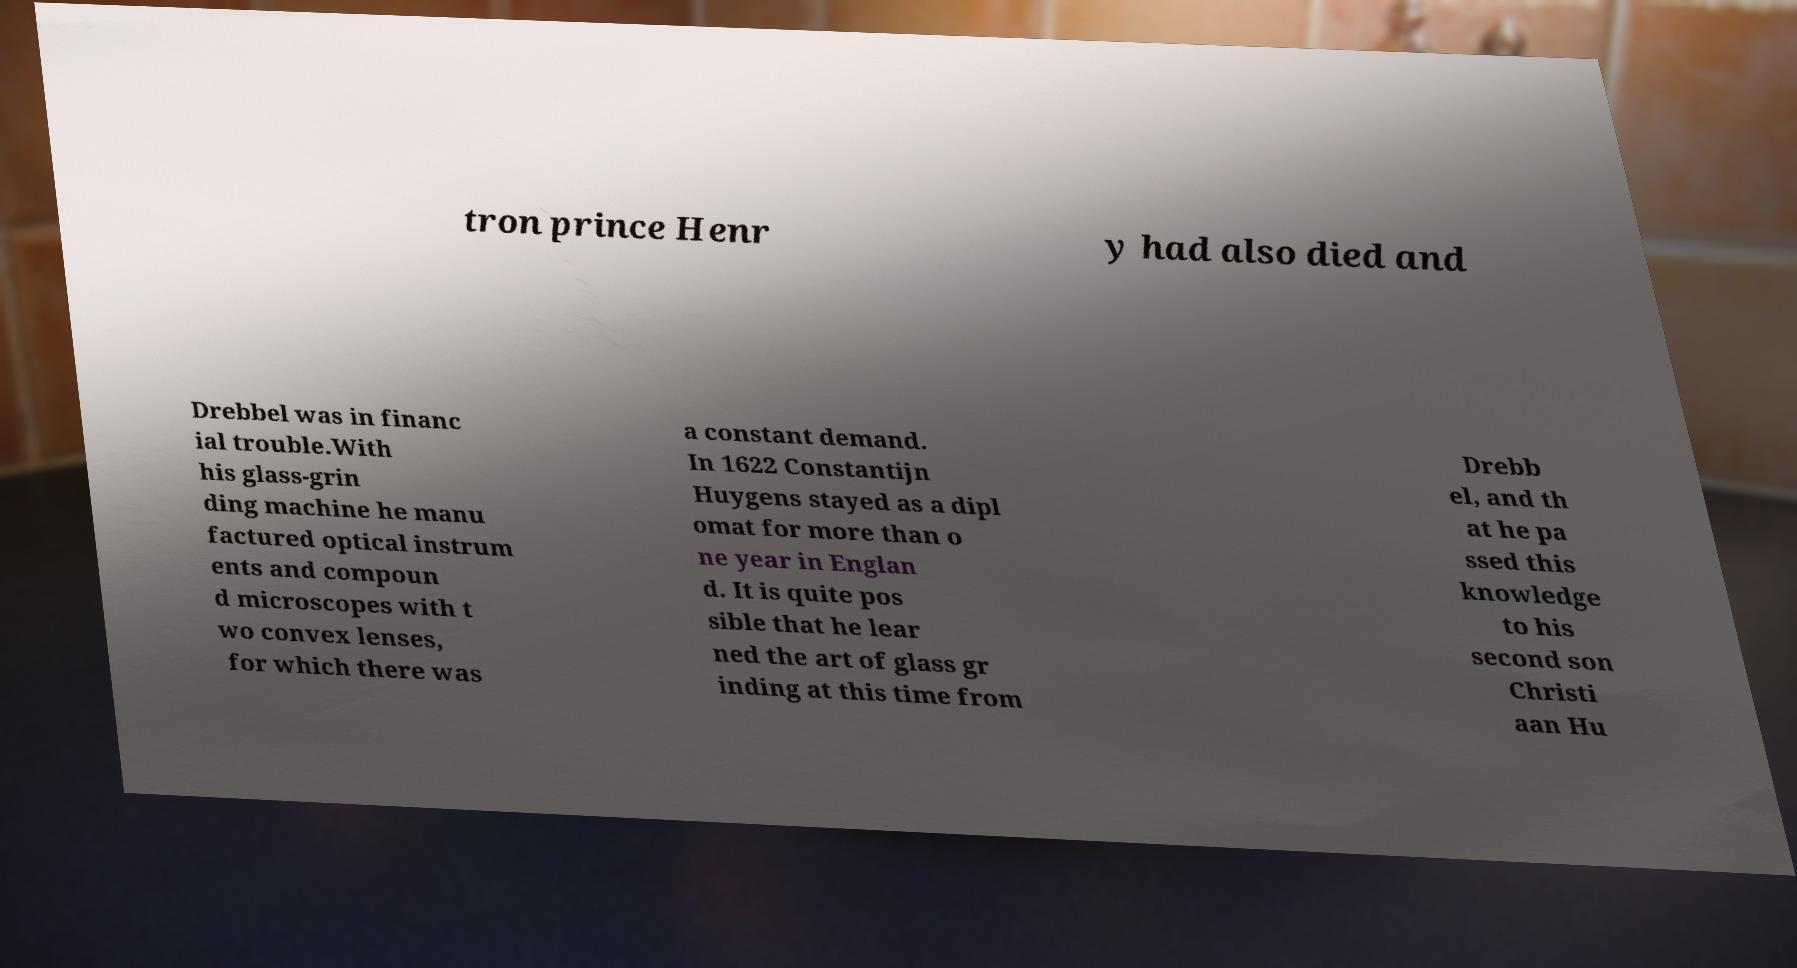There's text embedded in this image that I need extracted. Can you transcribe it verbatim? tron prince Henr y had also died and Drebbel was in financ ial trouble.With his glass-grin ding machine he manu factured optical instrum ents and compoun d microscopes with t wo convex lenses, for which there was a constant demand. In 1622 Constantijn Huygens stayed as a dipl omat for more than o ne year in Englan d. It is quite pos sible that he lear ned the art of glass gr inding at this time from Drebb el, and th at he pa ssed this knowledge to his second son Christi aan Hu 